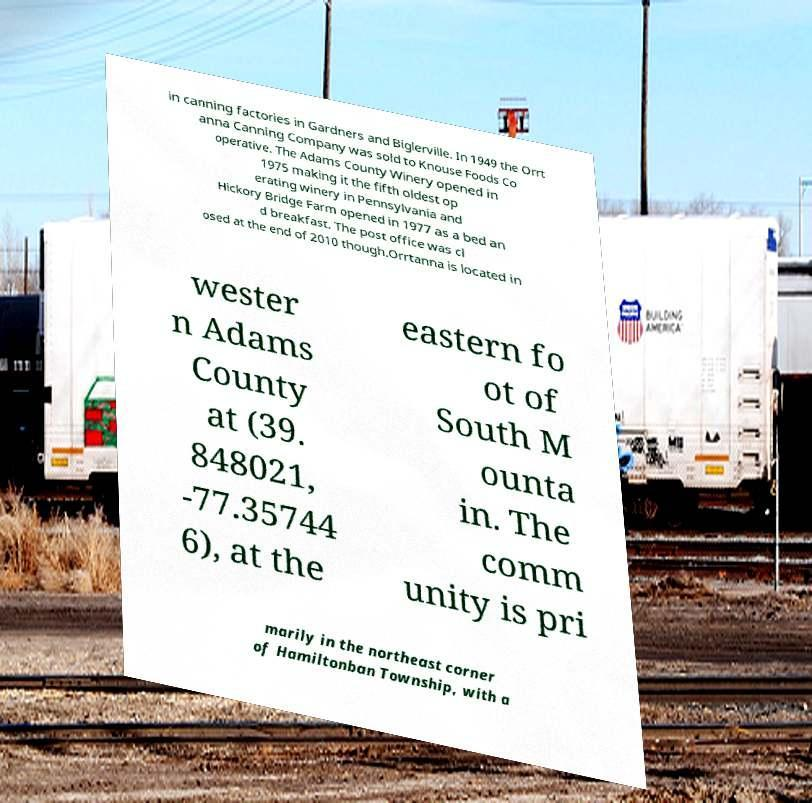There's text embedded in this image that I need extracted. Can you transcribe it verbatim? in canning factories in Gardners and Biglerville. In 1949 the Orrt anna Canning Company was sold to Knouse Foods Co operative. The Adams County Winery opened in 1975 making it the fifth oldest op erating winery in Pennsylvania and Hickory Bridge Farm opened in 1977 as a bed an d breakfast. The post office was cl osed at the end of 2010 though.Orrtanna is located in wester n Adams County at (39. 848021, -77.35744 6), at the eastern fo ot of South M ounta in. The comm unity is pri marily in the northeast corner of Hamiltonban Township, with a 